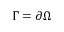Convert formula to latex. <formula><loc_0><loc_0><loc_500><loc_500>\Gamma = \partial \Omega</formula> 